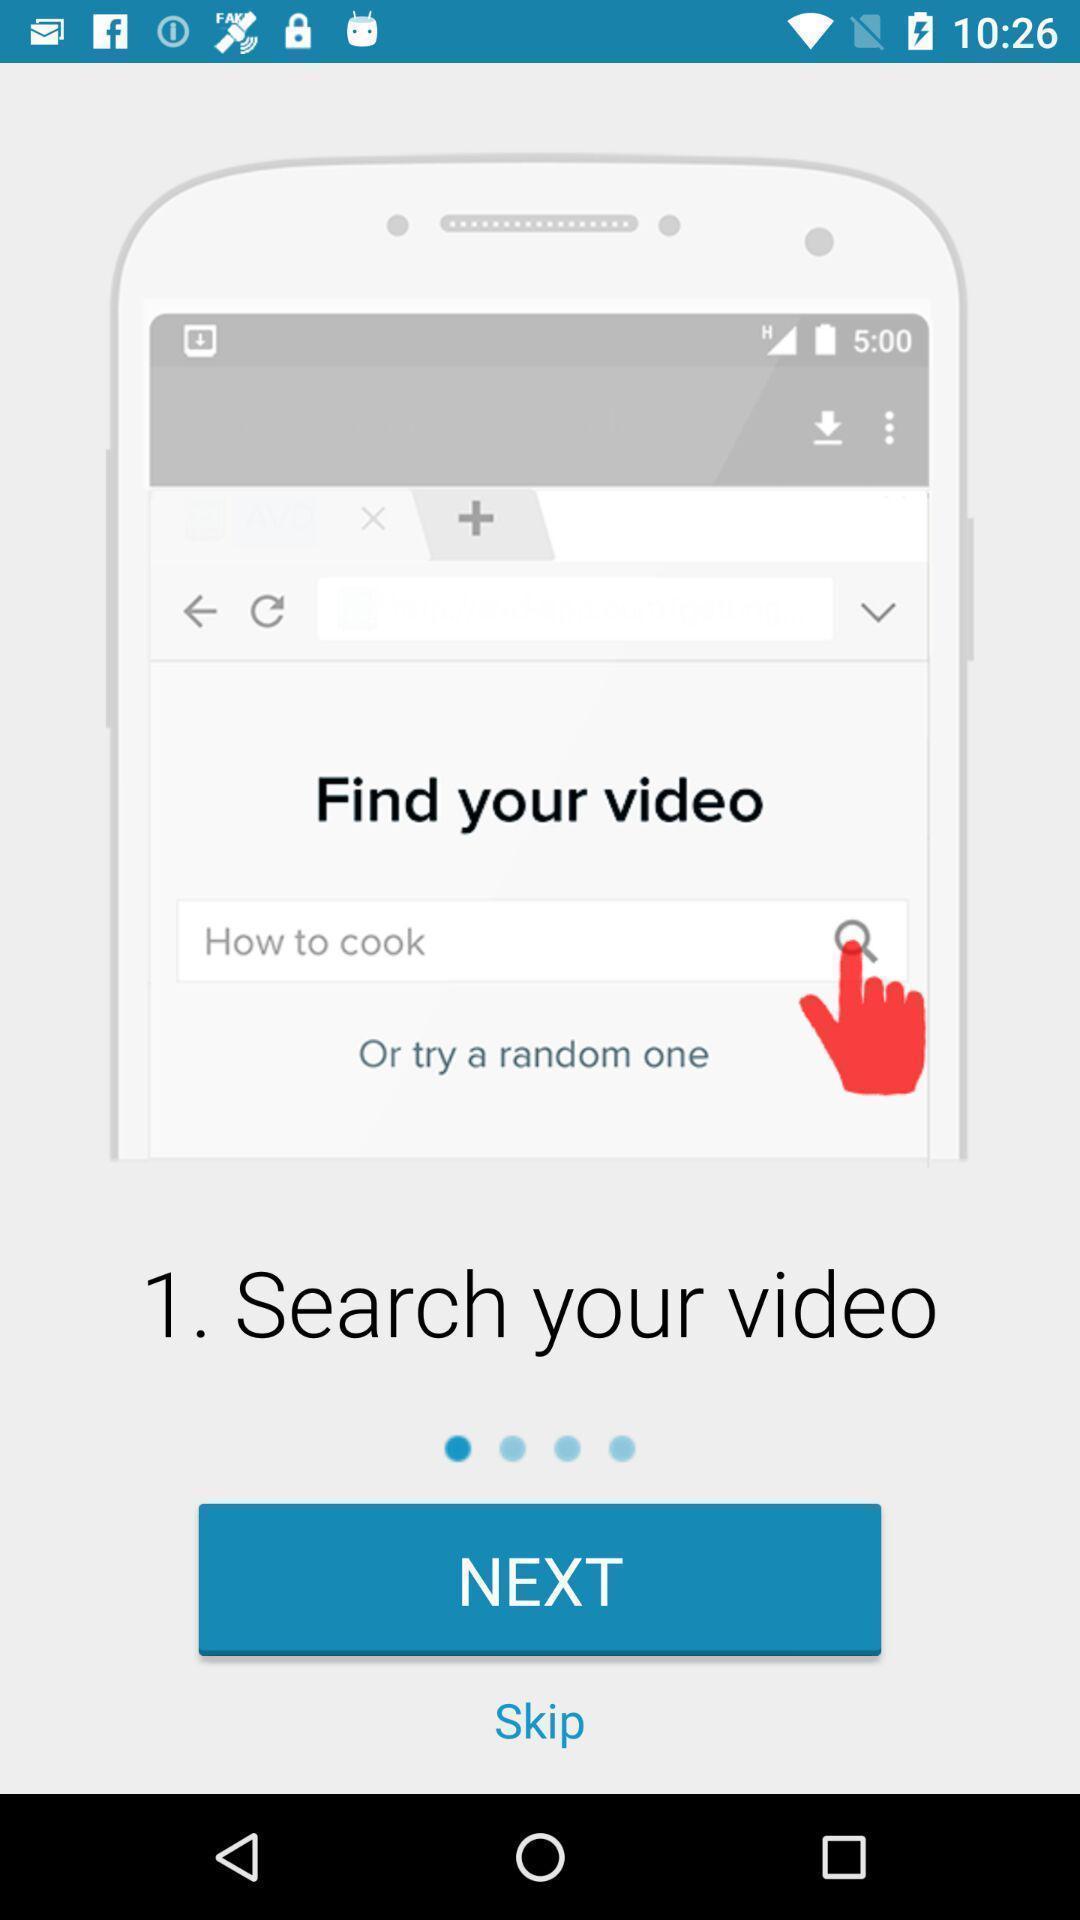Describe the content in this image. Welcome page. 